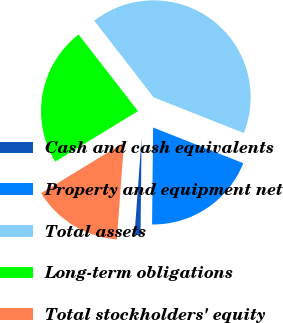Convert chart. <chart><loc_0><loc_0><loc_500><loc_500><pie_chart><fcel>Cash and cash equivalents<fcel>Property and equipment net<fcel>Total assets<fcel>Long-term obligations<fcel>Total stockholders' equity<nl><fcel>0.99%<fcel>19.17%<fcel>41.5%<fcel>23.22%<fcel>15.12%<nl></chart> 